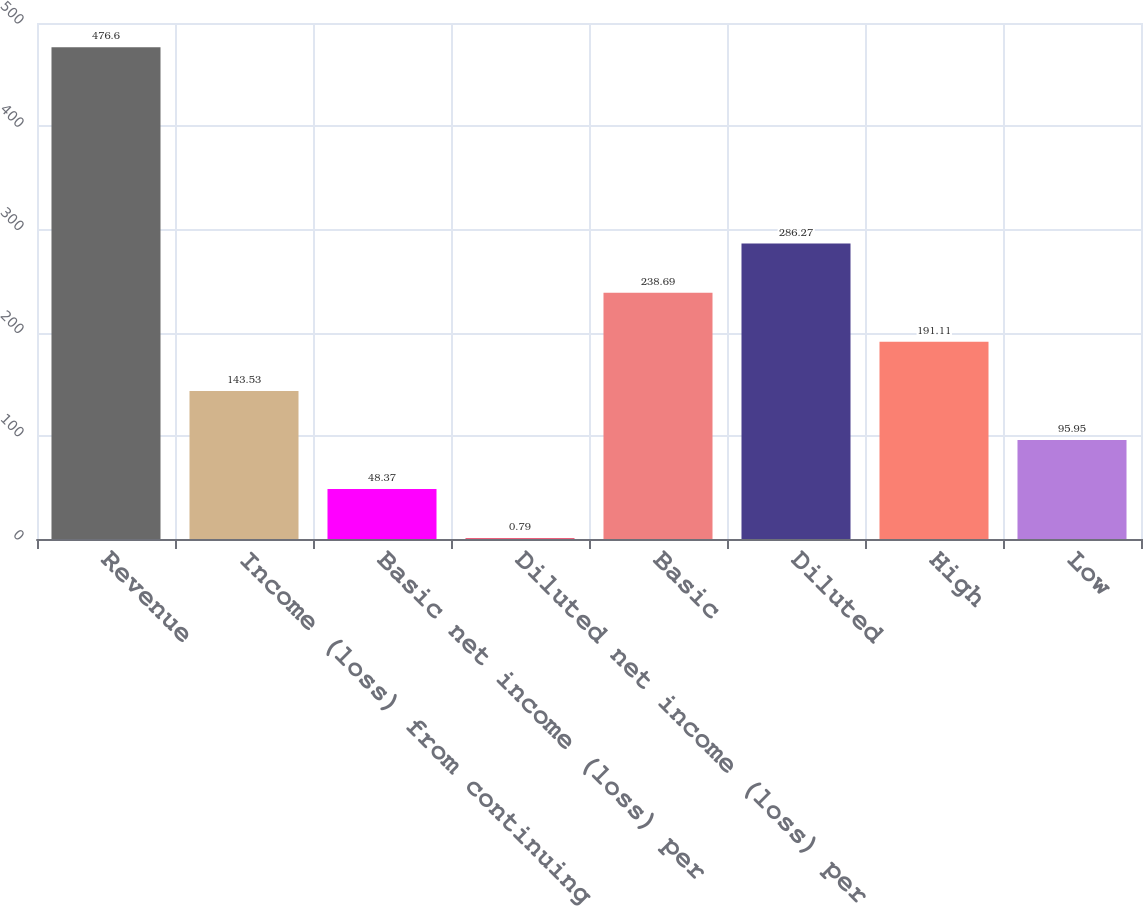Convert chart. <chart><loc_0><loc_0><loc_500><loc_500><bar_chart><fcel>Revenue<fcel>Income (loss) from continuing<fcel>Basic net income (loss) per<fcel>Diluted net income (loss) per<fcel>Basic<fcel>Diluted<fcel>High<fcel>Low<nl><fcel>476.6<fcel>143.53<fcel>48.37<fcel>0.79<fcel>238.69<fcel>286.27<fcel>191.11<fcel>95.95<nl></chart> 